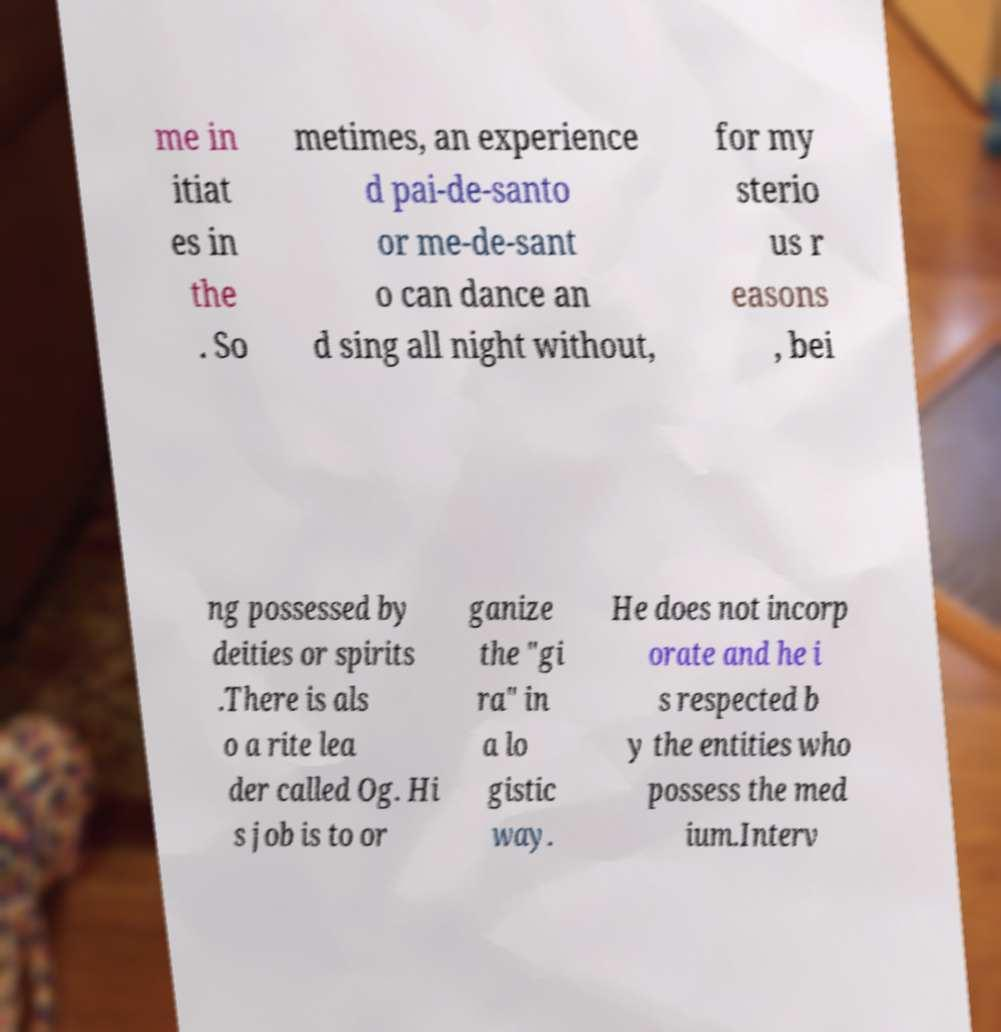For documentation purposes, I need the text within this image transcribed. Could you provide that? me in itiat es in the . So metimes, an experience d pai-de-santo or me-de-sant o can dance an d sing all night without, for my sterio us r easons , bei ng possessed by deities or spirits .There is als o a rite lea der called Og. Hi s job is to or ganize the "gi ra" in a lo gistic way. He does not incorp orate and he i s respected b y the entities who possess the med ium.Interv 